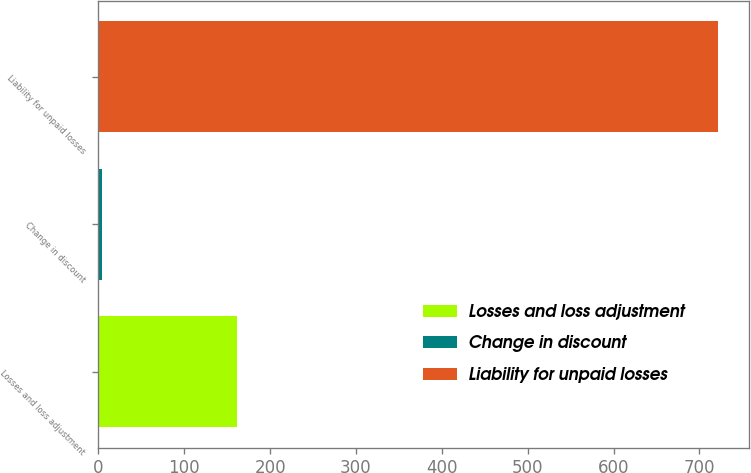Convert chart to OTSL. <chart><loc_0><loc_0><loc_500><loc_500><bar_chart><fcel>Losses and loss adjustment<fcel>Change in discount<fcel>Liability for unpaid losses<nl><fcel>162<fcel>4<fcel>722<nl></chart> 